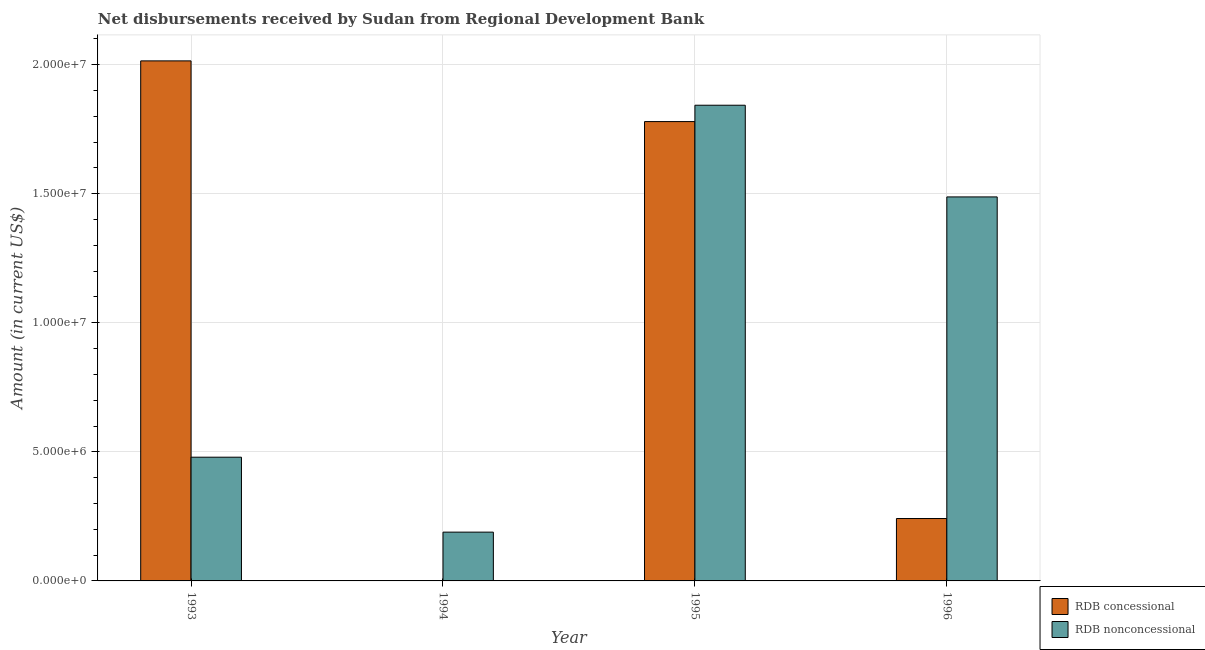Are the number of bars per tick equal to the number of legend labels?
Offer a terse response. No. Are the number of bars on each tick of the X-axis equal?
Keep it short and to the point. No. How many bars are there on the 3rd tick from the right?
Offer a very short reply. 1. In how many cases, is the number of bars for a given year not equal to the number of legend labels?
Provide a succinct answer. 1. What is the net non concessional disbursements from rdb in 1995?
Provide a short and direct response. 1.84e+07. Across all years, what is the maximum net non concessional disbursements from rdb?
Make the answer very short. 1.84e+07. Across all years, what is the minimum net concessional disbursements from rdb?
Your answer should be compact. 0. In which year was the net concessional disbursements from rdb maximum?
Offer a terse response. 1993. What is the total net non concessional disbursements from rdb in the graph?
Offer a terse response. 4.00e+07. What is the difference between the net concessional disbursements from rdb in 1993 and that in 1996?
Offer a very short reply. 1.77e+07. What is the difference between the net concessional disbursements from rdb in 1995 and the net non concessional disbursements from rdb in 1994?
Offer a terse response. 1.78e+07. What is the average net non concessional disbursements from rdb per year?
Ensure brevity in your answer.  1.00e+07. In how many years, is the net non concessional disbursements from rdb greater than 15000000 US$?
Your response must be concise. 1. What is the ratio of the net non concessional disbursements from rdb in 1993 to that in 1995?
Provide a succinct answer. 0.26. Is the difference between the net concessional disbursements from rdb in 1995 and 1996 greater than the difference between the net non concessional disbursements from rdb in 1995 and 1996?
Provide a succinct answer. No. What is the difference between the highest and the second highest net non concessional disbursements from rdb?
Your answer should be very brief. 3.55e+06. What is the difference between the highest and the lowest net concessional disbursements from rdb?
Offer a terse response. 2.01e+07. In how many years, is the net concessional disbursements from rdb greater than the average net concessional disbursements from rdb taken over all years?
Provide a short and direct response. 2. Is the sum of the net non concessional disbursements from rdb in 1993 and 1995 greater than the maximum net concessional disbursements from rdb across all years?
Give a very brief answer. Yes. How many bars are there?
Make the answer very short. 7. Are all the bars in the graph horizontal?
Keep it short and to the point. No. How many years are there in the graph?
Your response must be concise. 4. Where does the legend appear in the graph?
Your answer should be compact. Bottom right. How many legend labels are there?
Ensure brevity in your answer.  2. What is the title of the graph?
Your answer should be very brief. Net disbursements received by Sudan from Regional Development Bank. Does "From human activities" appear as one of the legend labels in the graph?
Ensure brevity in your answer.  No. What is the label or title of the X-axis?
Provide a succinct answer. Year. What is the label or title of the Y-axis?
Ensure brevity in your answer.  Amount (in current US$). What is the Amount (in current US$) in RDB concessional in 1993?
Your response must be concise. 2.01e+07. What is the Amount (in current US$) in RDB nonconcessional in 1993?
Make the answer very short. 4.79e+06. What is the Amount (in current US$) in RDB nonconcessional in 1994?
Your answer should be compact. 1.89e+06. What is the Amount (in current US$) of RDB concessional in 1995?
Make the answer very short. 1.78e+07. What is the Amount (in current US$) of RDB nonconcessional in 1995?
Make the answer very short. 1.84e+07. What is the Amount (in current US$) of RDB concessional in 1996?
Your answer should be compact. 2.42e+06. What is the Amount (in current US$) of RDB nonconcessional in 1996?
Ensure brevity in your answer.  1.49e+07. Across all years, what is the maximum Amount (in current US$) in RDB concessional?
Your answer should be compact. 2.01e+07. Across all years, what is the maximum Amount (in current US$) in RDB nonconcessional?
Offer a very short reply. 1.84e+07. Across all years, what is the minimum Amount (in current US$) in RDB nonconcessional?
Offer a very short reply. 1.89e+06. What is the total Amount (in current US$) of RDB concessional in the graph?
Your answer should be compact. 4.04e+07. What is the total Amount (in current US$) of RDB nonconcessional in the graph?
Your answer should be compact. 4.00e+07. What is the difference between the Amount (in current US$) in RDB nonconcessional in 1993 and that in 1994?
Provide a short and direct response. 2.90e+06. What is the difference between the Amount (in current US$) in RDB concessional in 1993 and that in 1995?
Offer a terse response. 2.35e+06. What is the difference between the Amount (in current US$) of RDB nonconcessional in 1993 and that in 1995?
Provide a short and direct response. -1.36e+07. What is the difference between the Amount (in current US$) of RDB concessional in 1993 and that in 1996?
Your response must be concise. 1.77e+07. What is the difference between the Amount (in current US$) of RDB nonconcessional in 1993 and that in 1996?
Give a very brief answer. -1.01e+07. What is the difference between the Amount (in current US$) in RDB nonconcessional in 1994 and that in 1995?
Offer a very short reply. -1.65e+07. What is the difference between the Amount (in current US$) of RDB nonconcessional in 1994 and that in 1996?
Your answer should be compact. -1.30e+07. What is the difference between the Amount (in current US$) in RDB concessional in 1995 and that in 1996?
Provide a succinct answer. 1.54e+07. What is the difference between the Amount (in current US$) in RDB nonconcessional in 1995 and that in 1996?
Ensure brevity in your answer.  3.55e+06. What is the difference between the Amount (in current US$) of RDB concessional in 1993 and the Amount (in current US$) of RDB nonconcessional in 1994?
Offer a terse response. 1.83e+07. What is the difference between the Amount (in current US$) of RDB concessional in 1993 and the Amount (in current US$) of RDB nonconcessional in 1995?
Provide a succinct answer. 1.72e+06. What is the difference between the Amount (in current US$) in RDB concessional in 1993 and the Amount (in current US$) in RDB nonconcessional in 1996?
Offer a terse response. 5.27e+06. What is the difference between the Amount (in current US$) of RDB concessional in 1995 and the Amount (in current US$) of RDB nonconcessional in 1996?
Give a very brief answer. 2.92e+06. What is the average Amount (in current US$) of RDB concessional per year?
Provide a succinct answer. 1.01e+07. What is the average Amount (in current US$) in RDB nonconcessional per year?
Give a very brief answer. 1.00e+07. In the year 1993, what is the difference between the Amount (in current US$) of RDB concessional and Amount (in current US$) of RDB nonconcessional?
Offer a terse response. 1.54e+07. In the year 1995, what is the difference between the Amount (in current US$) in RDB concessional and Amount (in current US$) in RDB nonconcessional?
Your response must be concise. -6.34e+05. In the year 1996, what is the difference between the Amount (in current US$) of RDB concessional and Amount (in current US$) of RDB nonconcessional?
Offer a very short reply. -1.25e+07. What is the ratio of the Amount (in current US$) of RDB nonconcessional in 1993 to that in 1994?
Give a very brief answer. 2.54. What is the ratio of the Amount (in current US$) in RDB concessional in 1993 to that in 1995?
Keep it short and to the point. 1.13. What is the ratio of the Amount (in current US$) of RDB nonconcessional in 1993 to that in 1995?
Your answer should be compact. 0.26. What is the ratio of the Amount (in current US$) of RDB concessional in 1993 to that in 1996?
Your response must be concise. 8.34. What is the ratio of the Amount (in current US$) in RDB nonconcessional in 1993 to that in 1996?
Provide a succinct answer. 0.32. What is the ratio of the Amount (in current US$) in RDB nonconcessional in 1994 to that in 1995?
Give a very brief answer. 0.1. What is the ratio of the Amount (in current US$) in RDB nonconcessional in 1994 to that in 1996?
Offer a terse response. 0.13. What is the ratio of the Amount (in current US$) in RDB concessional in 1995 to that in 1996?
Provide a succinct answer. 7.36. What is the ratio of the Amount (in current US$) in RDB nonconcessional in 1995 to that in 1996?
Offer a very short reply. 1.24. What is the difference between the highest and the second highest Amount (in current US$) in RDB concessional?
Your answer should be very brief. 2.35e+06. What is the difference between the highest and the second highest Amount (in current US$) of RDB nonconcessional?
Keep it short and to the point. 3.55e+06. What is the difference between the highest and the lowest Amount (in current US$) in RDB concessional?
Provide a succinct answer. 2.01e+07. What is the difference between the highest and the lowest Amount (in current US$) of RDB nonconcessional?
Give a very brief answer. 1.65e+07. 